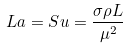<formula> <loc_0><loc_0><loc_500><loc_500>L a = S u = \frac { \sigma \rho L } { \mu ^ { 2 } }</formula> 